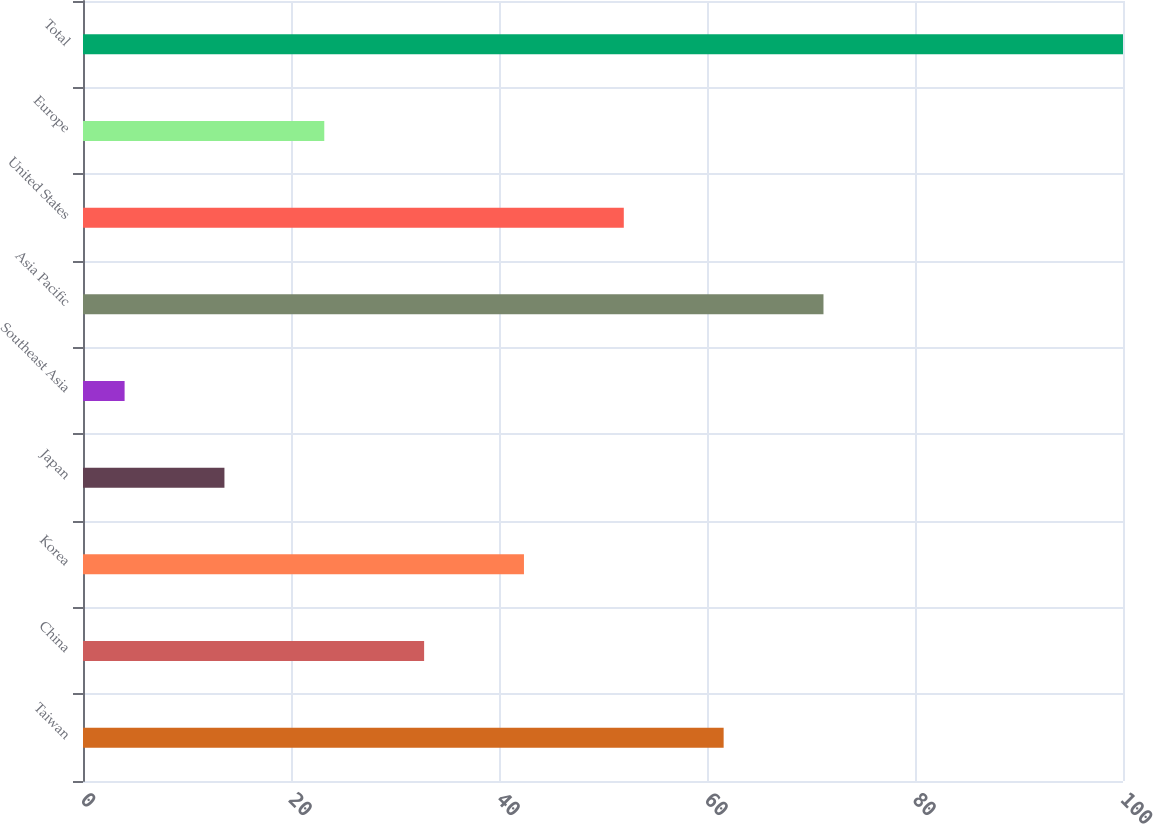Convert chart. <chart><loc_0><loc_0><loc_500><loc_500><bar_chart><fcel>Taiwan<fcel>China<fcel>Korea<fcel>Japan<fcel>Southeast Asia<fcel>Asia Pacific<fcel>United States<fcel>Europe<fcel>Total<nl><fcel>61.6<fcel>32.8<fcel>42.4<fcel>13.6<fcel>4<fcel>71.2<fcel>52<fcel>23.2<fcel>100<nl></chart> 